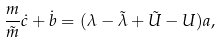<formula> <loc_0><loc_0><loc_500><loc_500>\frac { m } { \tilde { m } } \dot { c } + \dot { b } = ( \lambda - \tilde { \lambda } + { \tilde { U } } - U ) a ,</formula> 